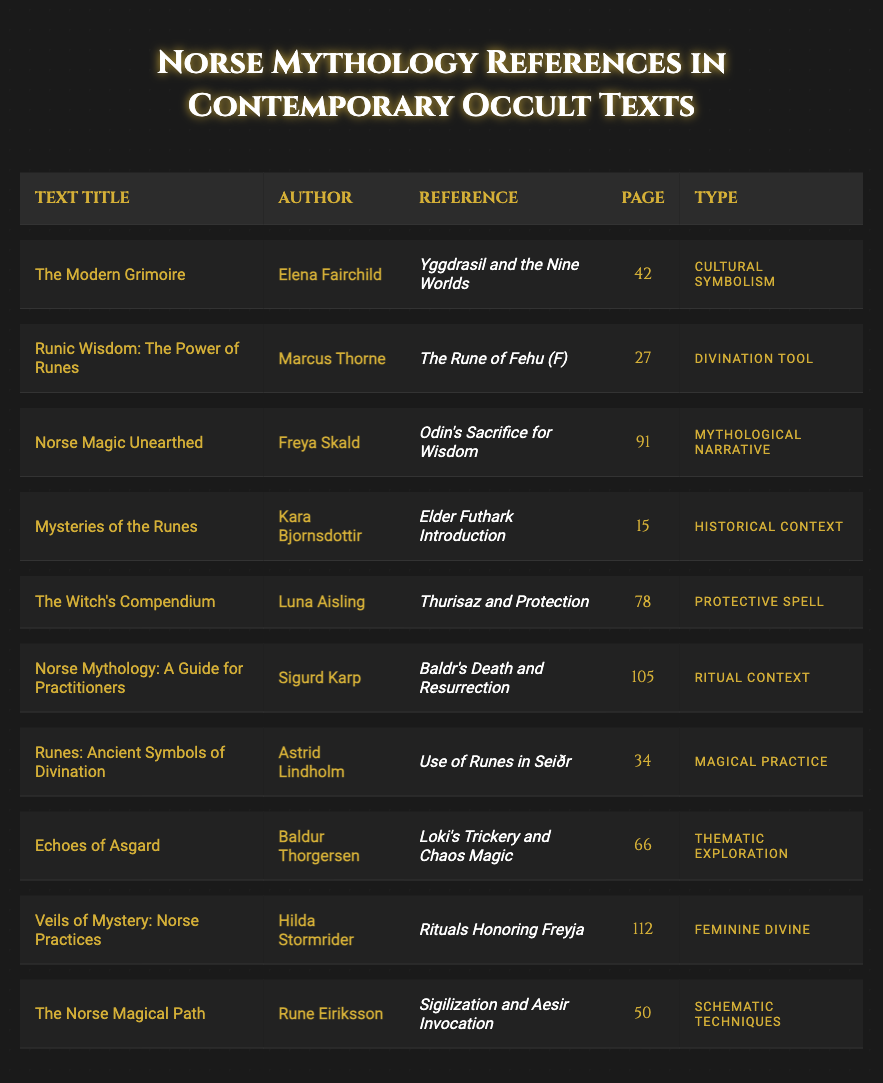What is the title of the text by Elena Fairchild? The table shows that Elena Fairchild is the author of "The Modern Grimoire."
Answer: The Modern Grimoire On which page can the reference "Odin's Sacrifice for Wisdom" be found? According to the table, "Odin's Sacrifice for Wisdom" is referenced on page 91 in "Norse Magic Unearthed."
Answer: 91 How many references are categorized as "Divination Tool"? The table shows that there is one divination tool, which is "The Rune of Fehu (F)" in "Runic Wisdom: The Power of Runes."
Answer: 1 What type of reference is "Thurisaz and Protection"? From the table, "Thurisaz and Protection" is categorized as a "Protective Spell" in "The Witch's Compendium."
Answer: Protective Spell Does "Runes: Ancient Symbols of Divination" discuss magical practices? Yes, the table indicates that "Runes: Ancient Symbols of Divination" includes references to "Use of Runes in Seiðr," which relates to magical practices.
Answer: Yes Which reference discusses feminine divine aspects? The table shows that "Rituals Honoring Freyja" in "Veils of Mystery: Norse Practices" discusses feminine divine aspects.
Answer: Rituals Honoring Freyja What is the average page number of references categorized under "Mythological Narrative" and "Ritual Context"? The references under these categories are on pages 91 ("Odin's Sacrifice for Wisdom") and 105 ("Baldr's Death and Resurrection"). The average is (91 + 105) / 2 = 98.
Answer: 98 What is the total number of texts authored by Hilda Stormrider? The table lists only one text authored by Hilda Stormrider, which is "Veils of Mystery: Norse Practices."
Answer: 1 Which author has the most entries in the table? By checking the table entries, each author appears to have only one entry, so no author has multiple entries.
Answer: None Which references occur on even-numbered pages? The references on even-numbered pages include page 42 ("Yggdrasil and the Nine Worlds"), page 78 ("Thurisaz and Protection"), page 112 ("Rituals Honoring Freyja"), and 50 ("Sigilization and Aesir Invocation").
Answer: Yggdrasil and the Nine Worlds, Thurisaz and Protection, Rituals Honoring Freyja, Sigilization and Aesir Invocation 